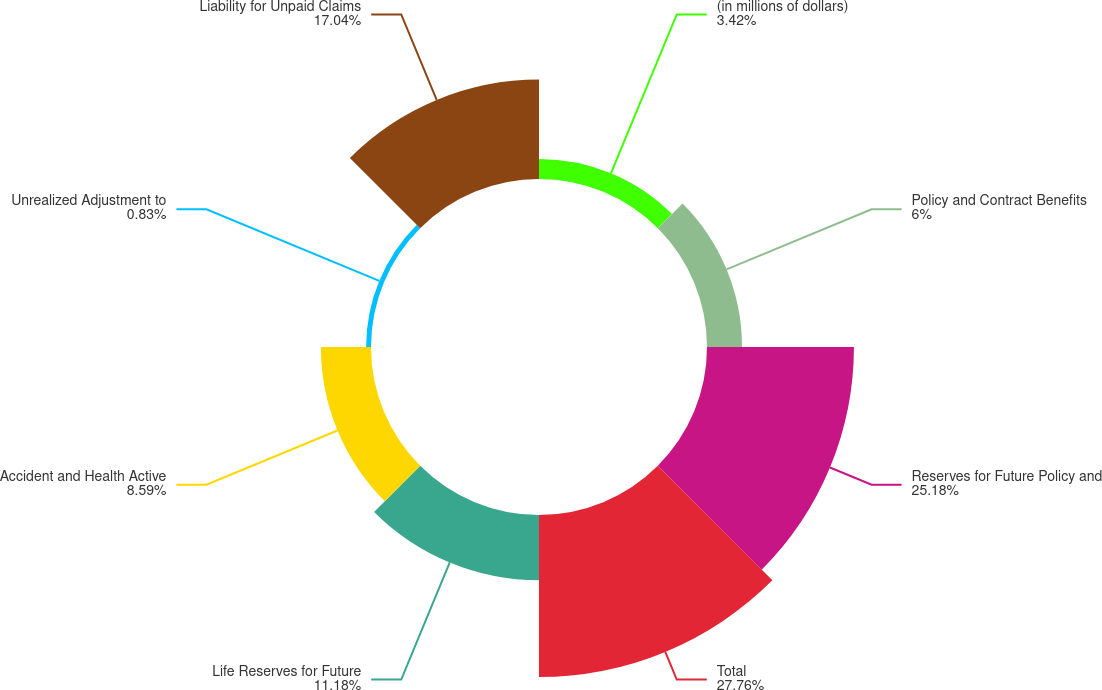Convert chart to OTSL. <chart><loc_0><loc_0><loc_500><loc_500><pie_chart><fcel>(in millions of dollars)<fcel>Policy and Contract Benefits<fcel>Reserves for Future Policy and<fcel>Total<fcel>Life Reserves for Future<fcel>Accident and Health Active<fcel>Unrealized Adjustment to<fcel>Liability for Unpaid Claims<nl><fcel>3.42%<fcel>6.0%<fcel>25.18%<fcel>27.76%<fcel>11.18%<fcel>8.59%<fcel>0.83%<fcel>17.04%<nl></chart> 